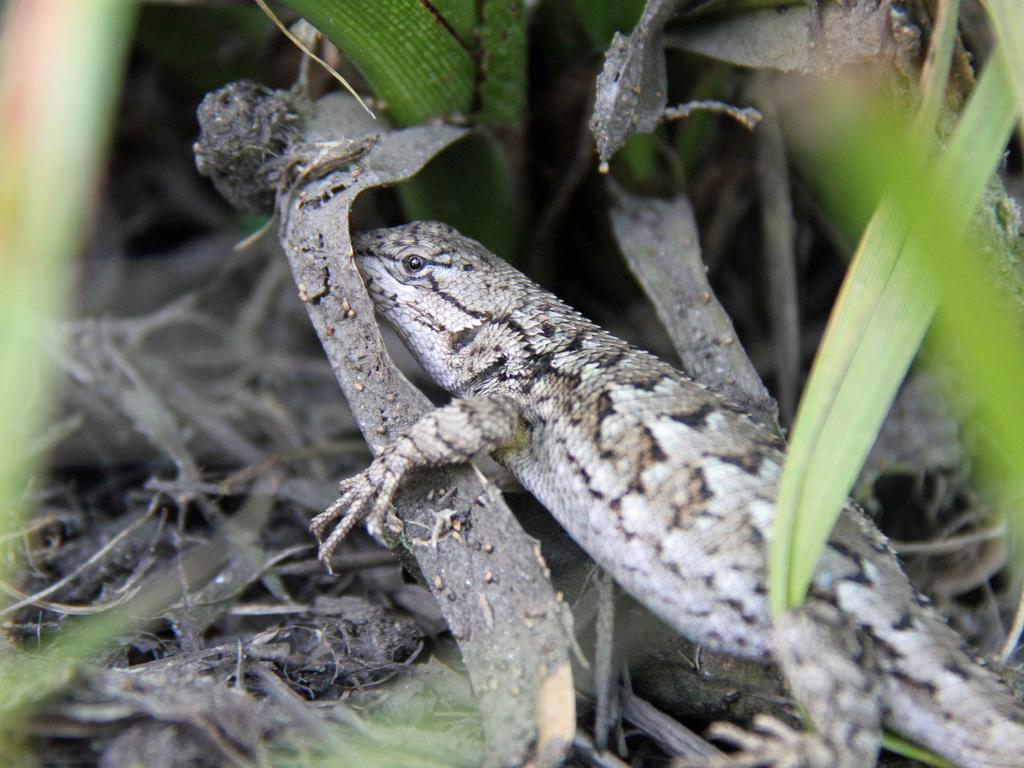What type of vegetation can be seen in the image? There are leaves in the image. What animal is located in the middle of the image? There is a lizard in the middle of the image. Is the lizard driving a car in the image? No, there is no car or driving activity depicted in the image. What type of cheese is present in the image? There is no cheese present in the image; it features leaves and a lizard. 